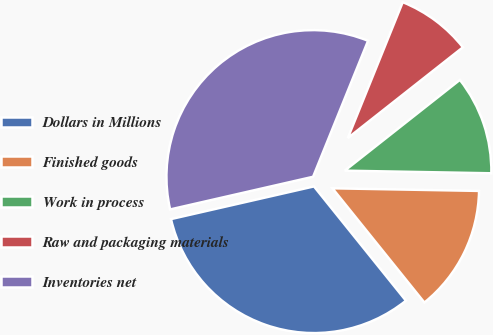Convert chart to OTSL. <chart><loc_0><loc_0><loc_500><loc_500><pie_chart><fcel>Dollars in Millions<fcel>Finished goods<fcel>Work in process<fcel>Raw and packaging materials<fcel>Inventories net<nl><fcel>32.21%<fcel>13.93%<fcel>10.91%<fcel>8.26%<fcel>34.69%<nl></chart> 